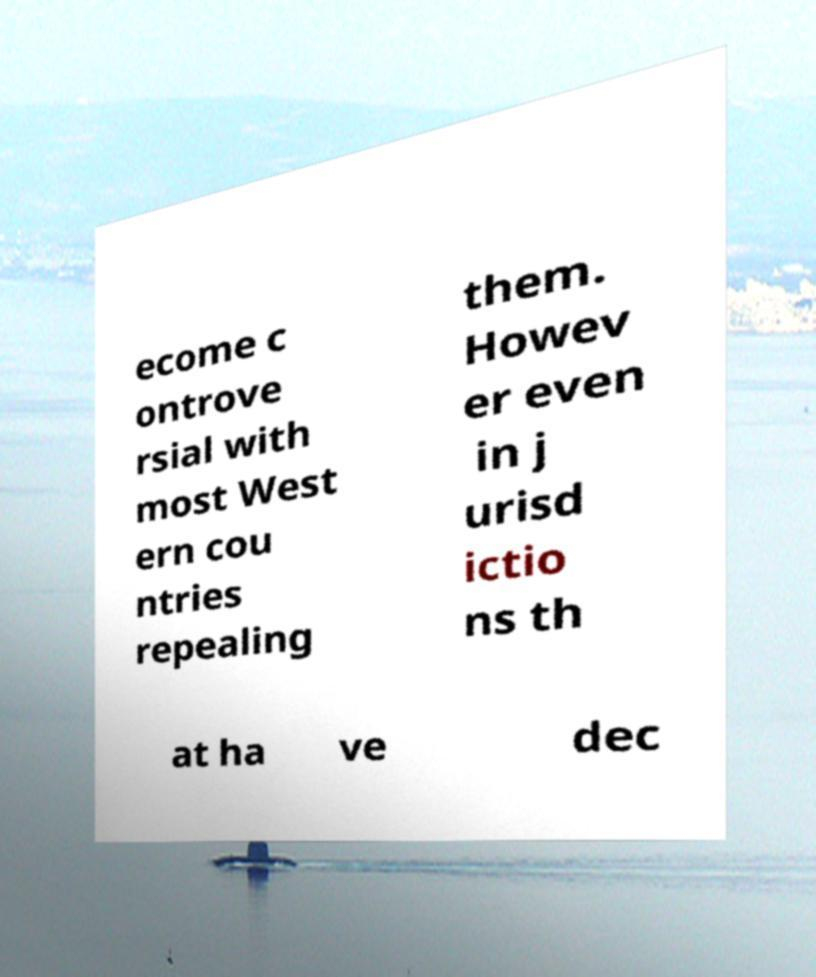What messages or text are displayed in this image? I need them in a readable, typed format. ecome c ontrove rsial with most West ern cou ntries repealing them. Howev er even in j urisd ictio ns th at ha ve dec 